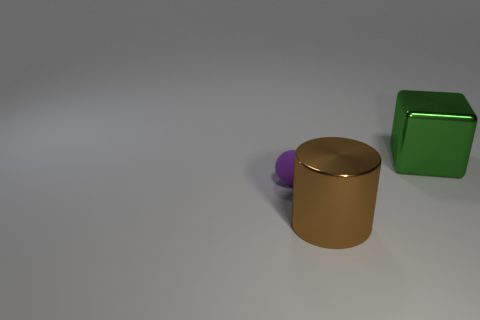Add 1 tiny purple objects. How many objects exist? 4 Subtract all cubes. How many objects are left? 2 Add 2 green metal things. How many green metal things are left? 3 Add 1 metal cylinders. How many metal cylinders exist? 2 Subtract 0 brown blocks. How many objects are left? 3 Subtract all tiny balls. Subtract all big cyan metallic blocks. How many objects are left? 2 